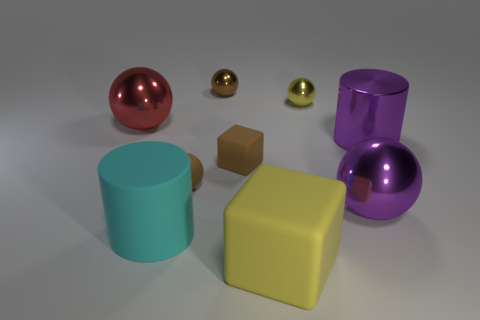Subtract 1 balls. How many balls are left? 4 Subtract all cyan spheres. Subtract all yellow cubes. How many spheres are left? 5 Add 1 large purple shiny spheres. How many objects exist? 10 Subtract all cylinders. How many objects are left? 7 Add 1 brown matte cubes. How many brown matte cubes exist? 2 Subtract 1 purple balls. How many objects are left? 8 Subtract all brown metallic objects. Subtract all yellow matte things. How many objects are left? 7 Add 8 purple metallic spheres. How many purple metallic spheres are left? 9 